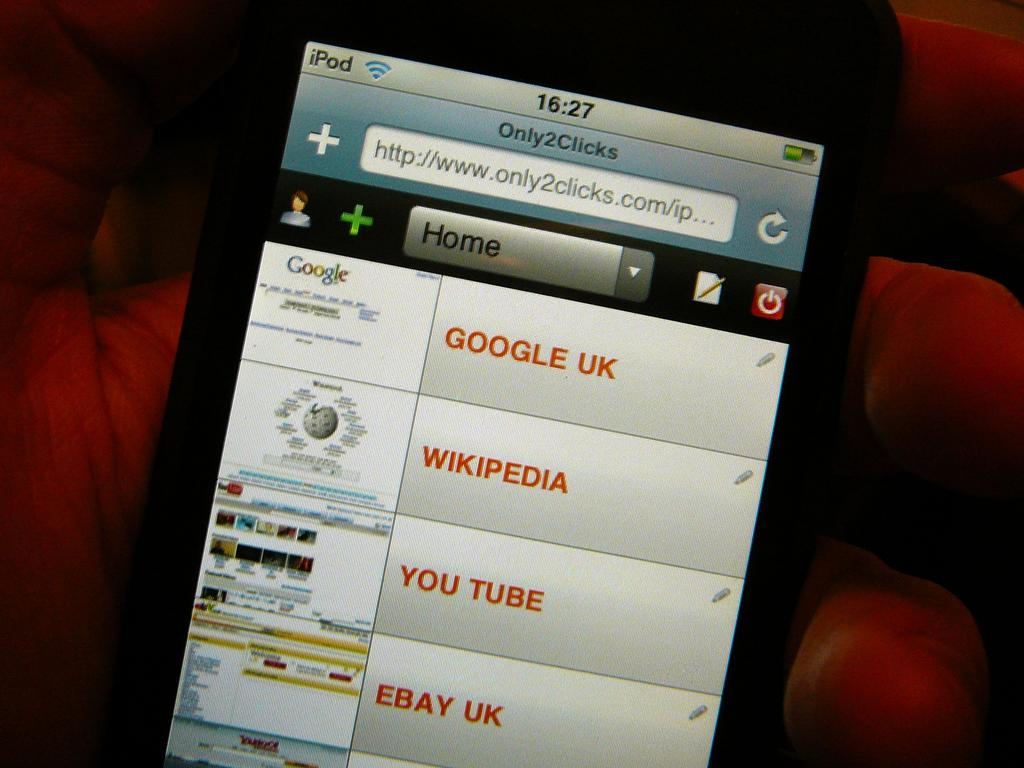<image>
Describe the image concisely. The screen of a cell phone with tabs for Google UK, Wikipedia, and other sites showing. 